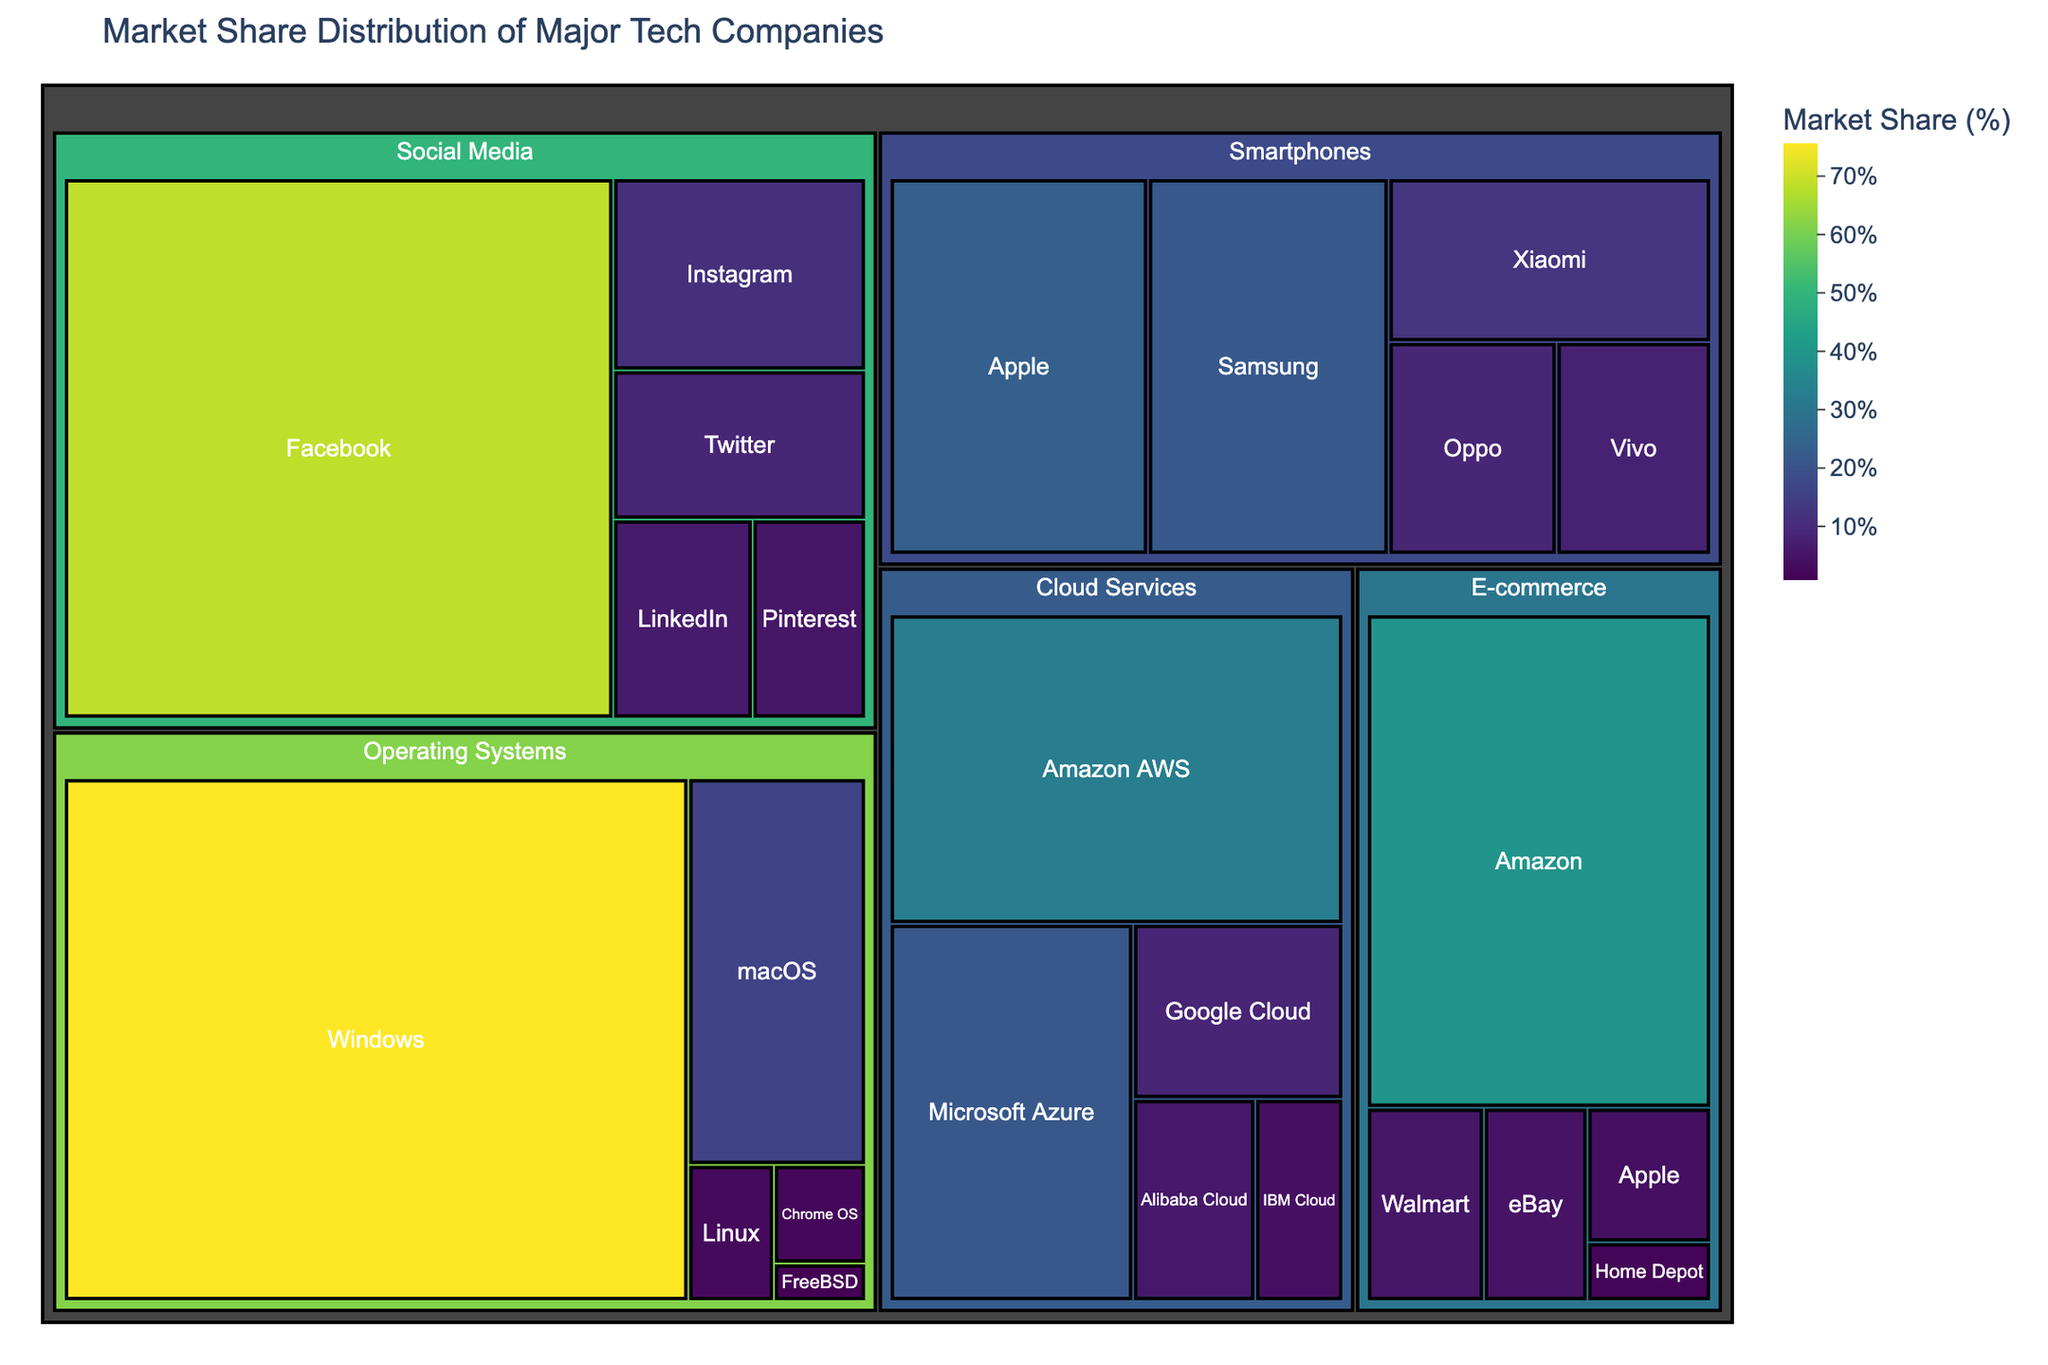What's the title of the treemap? The title is written at the top of the treemap. It provides context and describes what the figure represents.
Answer: Market Share Distribution of Major Tech Companies Which company has the largest market share in Cloud Services? In the Cloud Services category, the company with the largest area (which represents a higher market share) should be identified.
Answer: Amazon AWS What is the market share of macOS in Operating Systems? Locate the Operating Systems category, then find macOS within it and note the market share percentage displayed.
Answer: 15.9% How does the market share of Windows compare to macOS in Operating Systems? Identify the market shares of both Windows and macOS in the Operating Systems category and compare the two numbers; Windows has 75.6% and macOS has 15.9%.
Answer: Windows has a significantly larger market share than macOS What is the combined market share of Apple in both Smartphones and E-commerce? Find Apple's market share in both Smartphones and E-commerce categories, then sum them up (23.4% in Smartphones + 3.9% in E-commerce).
Answer: 27.3% How does the market share of Alibaba Cloud compare to IBM Cloud in Cloud Services? Locate market shares of Alibaba Cloud and IBM Cloud, then compare 5.7% (Alibaba Cloud) to 4.1% (IBM Cloud).
Answer: Alibaba Cloud has a higher market share than IBM Cloud Which Social Media platform has the second-largest market share? Within the Social Media category, identify the platform with the second largest area (second highest percentage) after Facebook, which is 68.5%.
Answer: Instagram What is the total market share of the top three companies in Smartphones? Sum the market shares of the top three companies in the Smartphones category: Apple (23.4%), Samsung (21.8%), and Xiaomi (12.7%).
Answer: 57.9% What product category has the most companies listed? Count the number of companies in each category. Social Media has five companies (Facebook, Instagram, Twitter, LinkedIn, Pinterest), which appears to be the most.
Answer: Social Media In E-commerce, how does Amazon's market share compare to the combined market share of Walmart and eBay? Find Amazon's market share (39.8%) and add the market shares of Walmart (5.3%) and eBay (4.7%), then compare the two sums.
Answer: Amazon has a higher market share than the combined market share of Walmart and eBay 